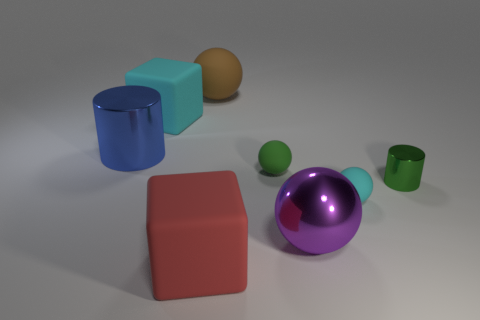Add 2 tiny gray shiny balls. How many objects exist? 10 Subtract all green balls. Subtract all big brown things. How many objects are left? 6 Add 6 small matte balls. How many small matte balls are left? 8 Add 5 big matte balls. How many big matte balls exist? 6 Subtract 0 yellow balls. How many objects are left? 8 